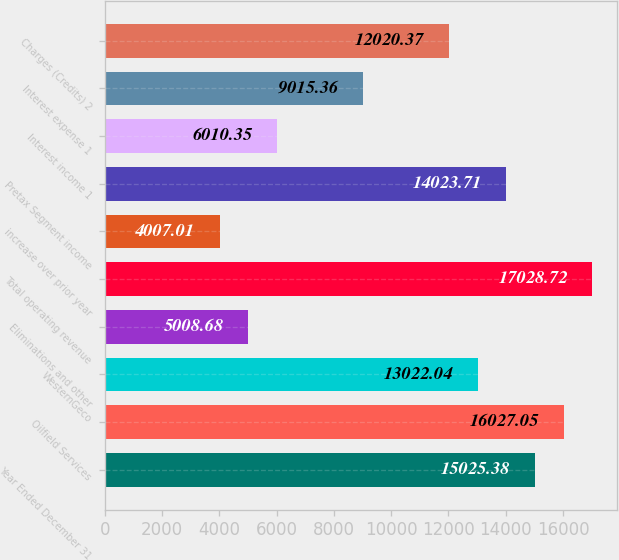Convert chart to OTSL. <chart><loc_0><loc_0><loc_500><loc_500><bar_chart><fcel>Year Ended December 31<fcel>Oilfield Services<fcel>WesternGeco<fcel>Eliminations and other<fcel>Total operating revenue<fcel>increase over prior year<fcel>Pretax Segment income<fcel>Interest income 1<fcel>Interest expense 1<fcel>Charges (Credits) 2<nl><fcel>15025.4<fcel>16027<fcel>13022<fcel>5008.68<fcel>17028.7<fcel>4007.01<fcel>14023.7<fcel>6010.35<fcel>9015.36<fcel>12020.4<nl></chart> 